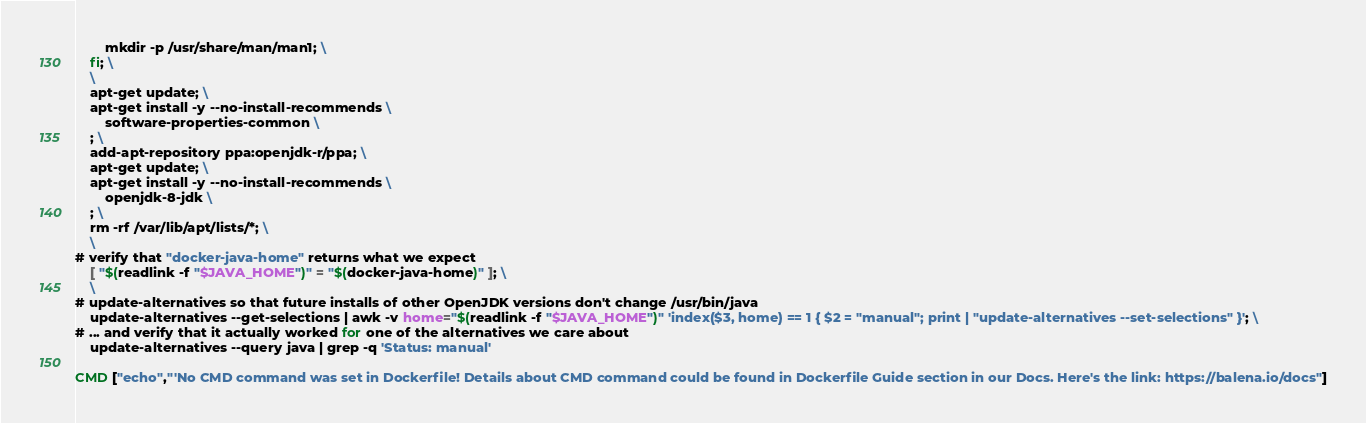Convert code to text. <code><loc_0><loc_0><loc_500><loc_500><_Dockerfile_>		mkdir -p /usr/share/man/man1; \
	fi; \
	\
	apt-get update; \
	apt-get install -y --no-install-recommends \
		software-properties-common \
	; \
	add-apt-repository ppa:openjdk-r/ppa; \
	apt-get update; \
	apt-get install -y --no-install-recommends \
		openjdk-8-jdk \
	; \
	rm -rf /var/lib/apt/lists/*; \
	\
# verify that "docker-java-home" returns what we expect
	[ "$(readlink -f "$JAVA_HOME")" = "$(docker-java-home)" ]; \
	\
# update-alternatives so that future installs of other OpenJDK versions don't change /usr/bin/java
	update-alternatives --get-selections | awk -v home="$(readlink -f "$JAVA_HOME")" 'index($3, home) == 1 { $2 = "manual"; print | "update-alternatives --set-selections" }'; \
# ... and verify that it actually worked for one of the alternatives we care about
	update-alternatives --query java | grep -q 'Status: manual'

CMD ["echo","'No CMD command was set in Dockerfile! Details about CMD command could be found in Dockerfile Guide section in our Docs. Here's the link: https://balena.io/docs"]</code> 